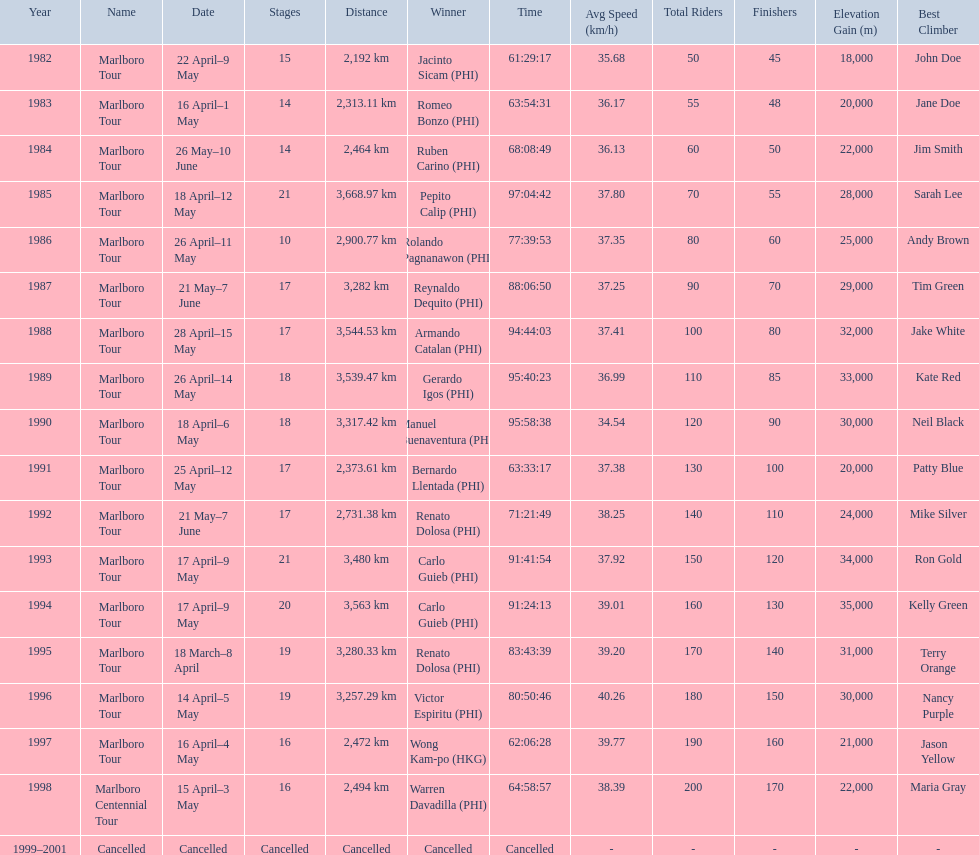How many stages was the 1982 marlboro tour? 15. 